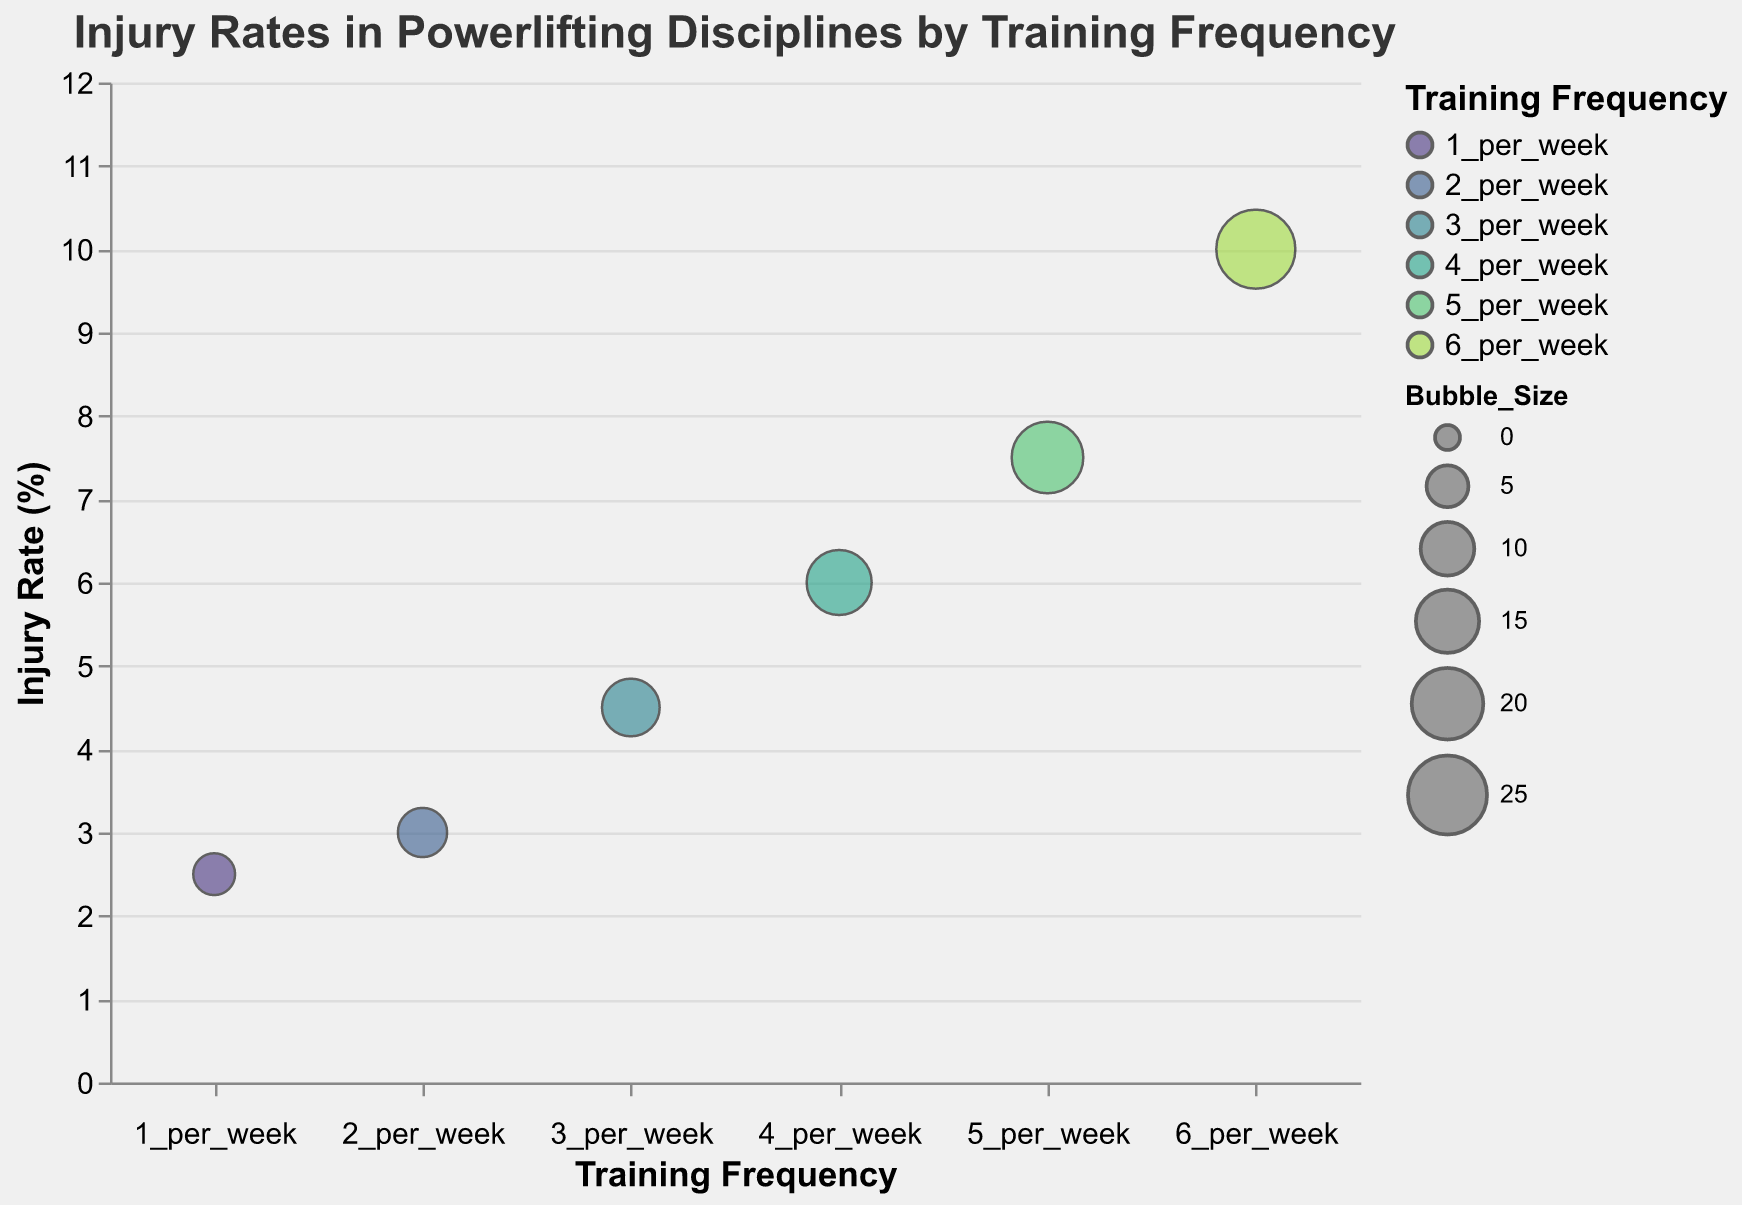What is the title of the figure? The title is usually located at the top of the figure and summarizes the main topic being visualized. The title here reads "Injury Rates in Powerlifting Disciplines by Training Frequency".
Answer: Injury Rates in Powerlifting Disciplines by Training Frequency How many different training frequencies are represented in the figure? The training frequencies are shown along the x-axis and in the legend. There are six distinct categories: "1_per_week", "2_per_week", "3_per_week", "4_per_week", "5_per_week", and "6_per_week".
Answer: Six Which training frequency corresponds to the highest injury rate? By looking at the y-axis values for injury rate and identifying which bubble corresponds to the highest point, the training frequency "6_per_week" is at the top.
Answer: 6_per_week What is the average injury rate across all training frequencies? Sum the injury rates for all training frequencies (2.5 + 3.0 + 4.5 + 6.0 + 7.5 + 10.0) and then divide by the number of frequencies (6). The calculation is (2.5 + 3.0 + 4.5 + 6.0 + 7.5 + 10.0) / 6 = 33.5 / 6.
Answer: 5.58 Which exercise has the highest injury rate when training 3 times per week? By checking the tooltips for the data point corresponding to "3_per_week", the injury rates for squat, bench press, and deadlift are 3.1, 2.9, and 4.0 respectively. The deadlift has the highest injury rate.
Answer: Deadlift How do the injury rates change as the training frequency increases from once to six times per week? By observing the trend of bubbles on the y-axis from left to right, we see the injury rate increases progressively from 2.5% (1_per_week) to 10.0% (6_per_week).
Answer: Injury rates increase What is the difference in injury rates between the highest and lowest training frequencies? Subtract the injury rate for "1_per_week" (2.5%) from the injury rate for "6_per_week" (10.0%). The calculation is 10.0 - 2.5.
Answer: 7.5% At what training frequency do the bubbles have the largest size? The size of the bubbles corresponds to "Bubble_Size" which increases the most at "6_per_week" (25).
Answer: 6_per_week Compare the injury rates of the bench press injury at "5_per_week" versus "6_per_week". The injury rates for bench press at 5 and 6 times per week are shown in the tooltips: 4.5% and 5.8% respectively.
Answer: 6_per_week is higher 